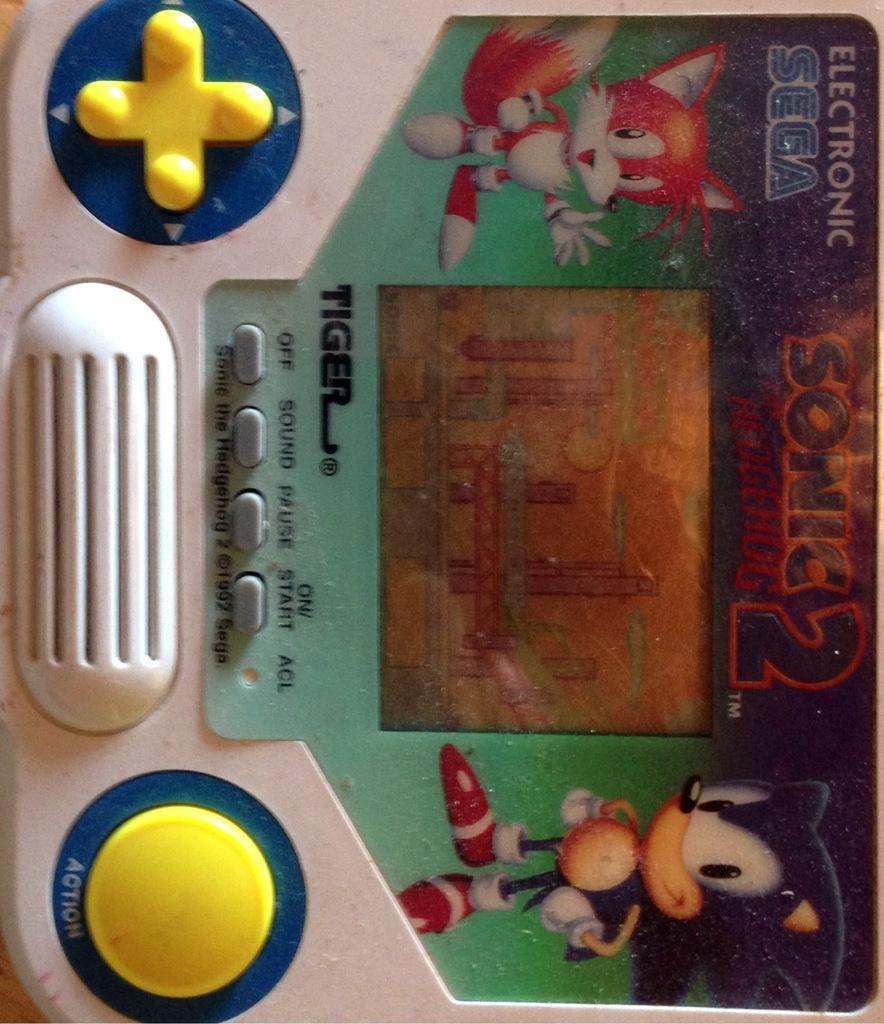Can you describe this image briefly? This image consists of a video game. The buttons are in yellow color. There are cartoon stickers on it. 